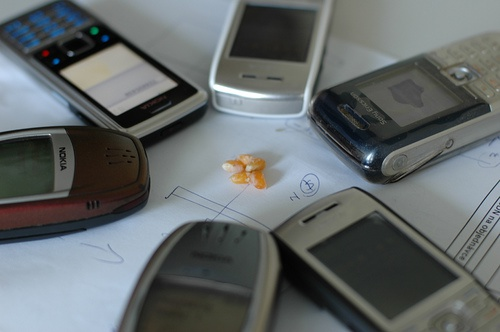Describe the objects in this image and their specific colors. I can see cell phone in darkgray, black, gray, and darkblue tones, cell phone in darkgray, black, gray, and blue tones, cell phone in darkgray, black, maroon, and gray tones, cell phone in darkgray, gray, and black tones, and cell phone in darkgray, black, and gray tones in this image. 